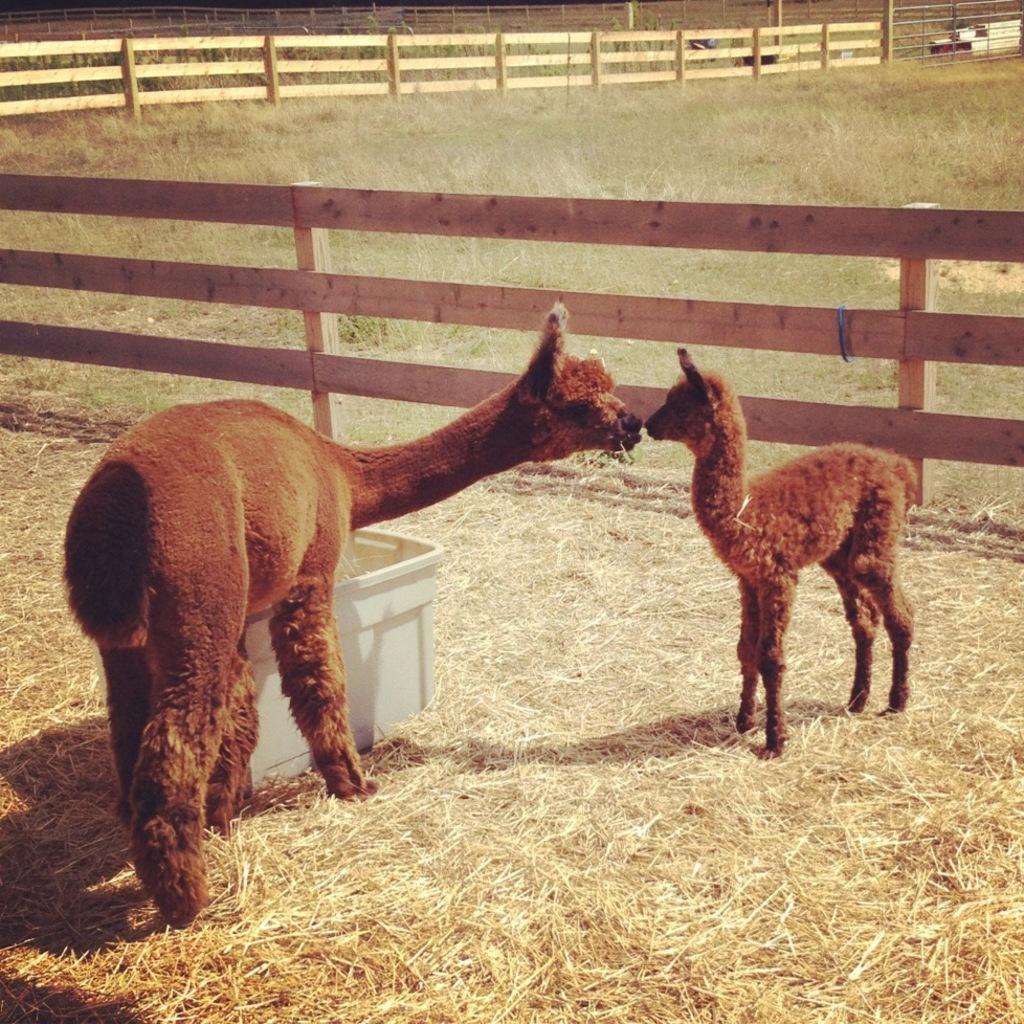Describe this image in one or two sentences. In this picture we can observe two animals which were in brown color. There is some dried grass on the land. We can observe a white color box here. There is a wooden railing. In the background there is an open ground. 